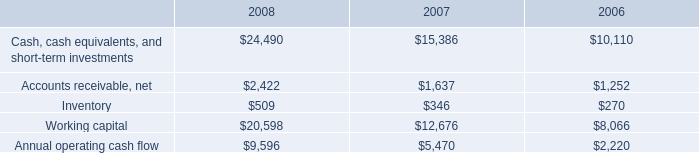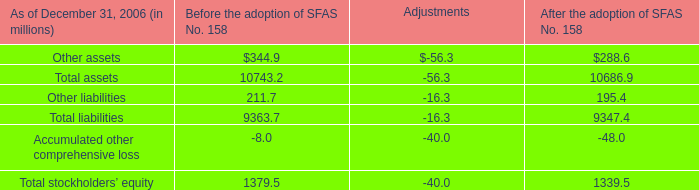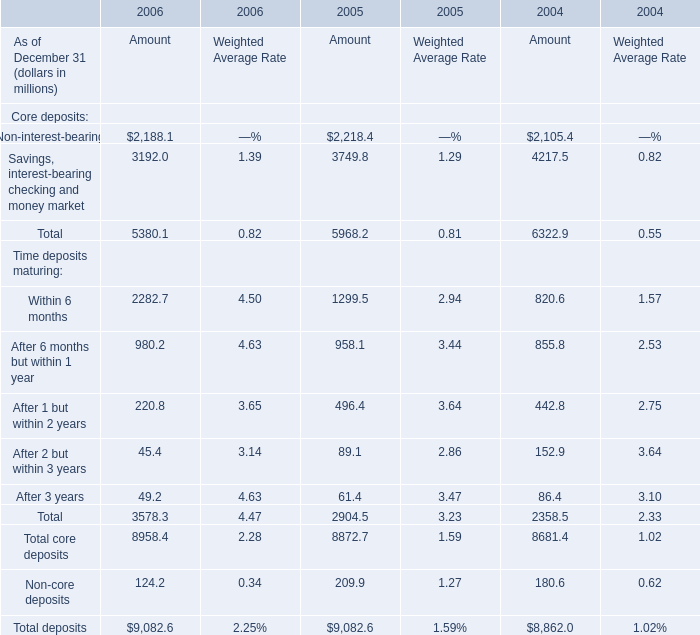Does the value of total Core deposits in 2006 greater than that in 2005? 
Answer: No. 